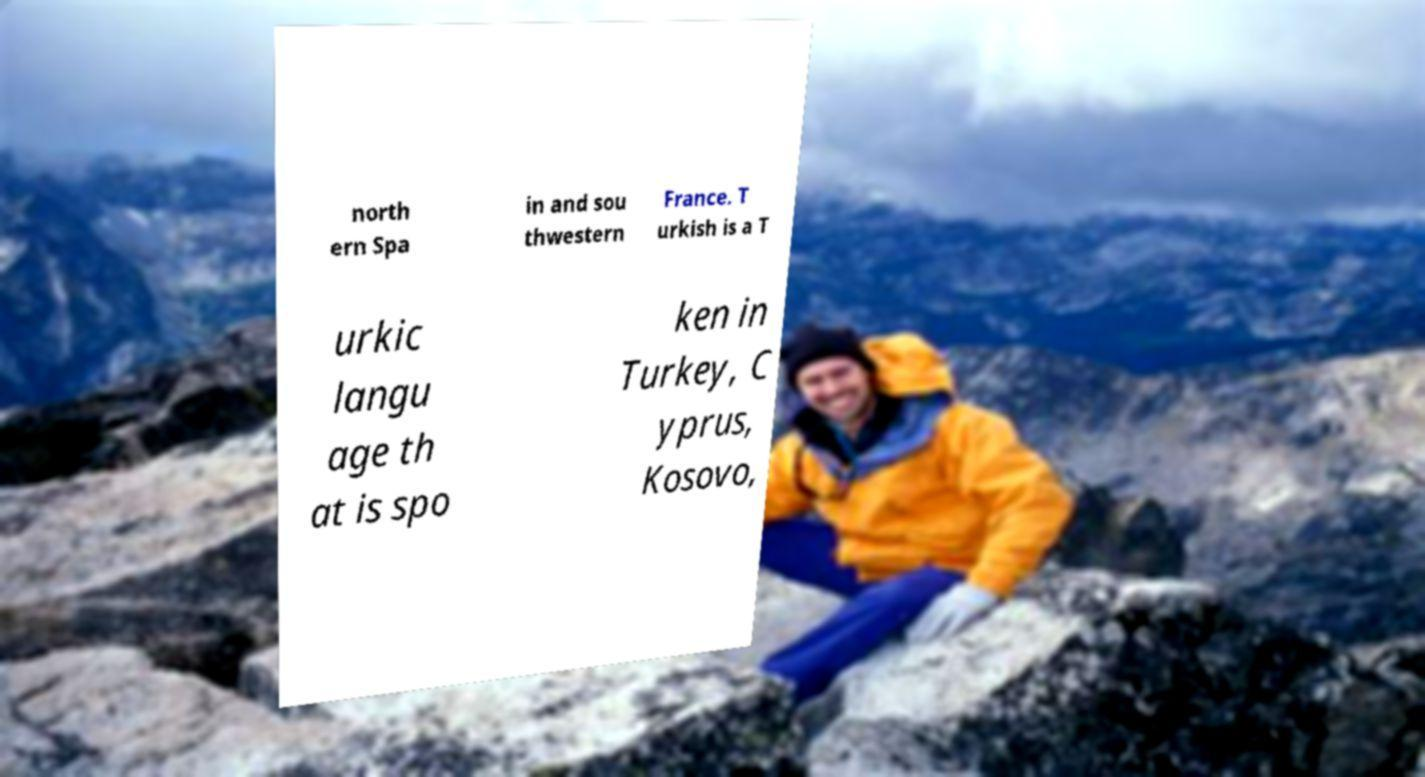Could you assist in decoding the text presented in this image and type it out clearly? north ern Spa in and sou thwestern France. T urkish is a T urkic langu age th at is spo ken in Turkey, C yprus, Kosovo, 